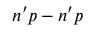<formula> <loc_0><loc_0><loc_500><loc_500>n ^ { \prime } p - n ^ { \prime } p</formula> 